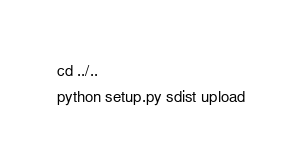<code> <loc_0><loc_0><loc_500><loc_500><_Bash_>cd ../..
python setup.py sdist upload

</code> 